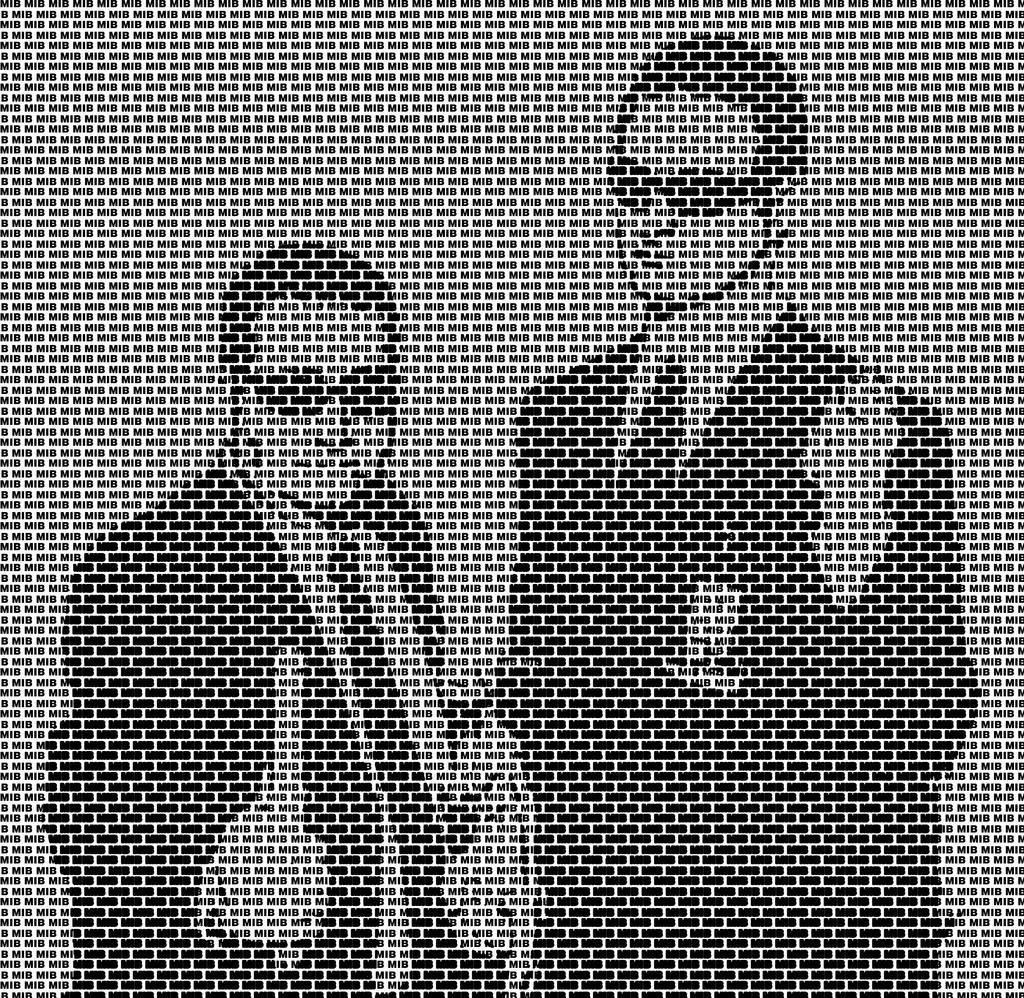What is the color scheme of the image? The image is monochrome. Can you describe the man on the right side of the image? The man on the right side of the image is wearing a suit and goggles. Who is beside the man in the suit? There is another man beside the first man. What is the second man holding? The second man is holding a pipe. Are the two men in the image brothers? There is no information provided about the relationship between the two men in the image. Can you see any bubbles in the image? There is no mention of bubbles in the provided facts, so we cannot determine if there are any bubbles in the image. 